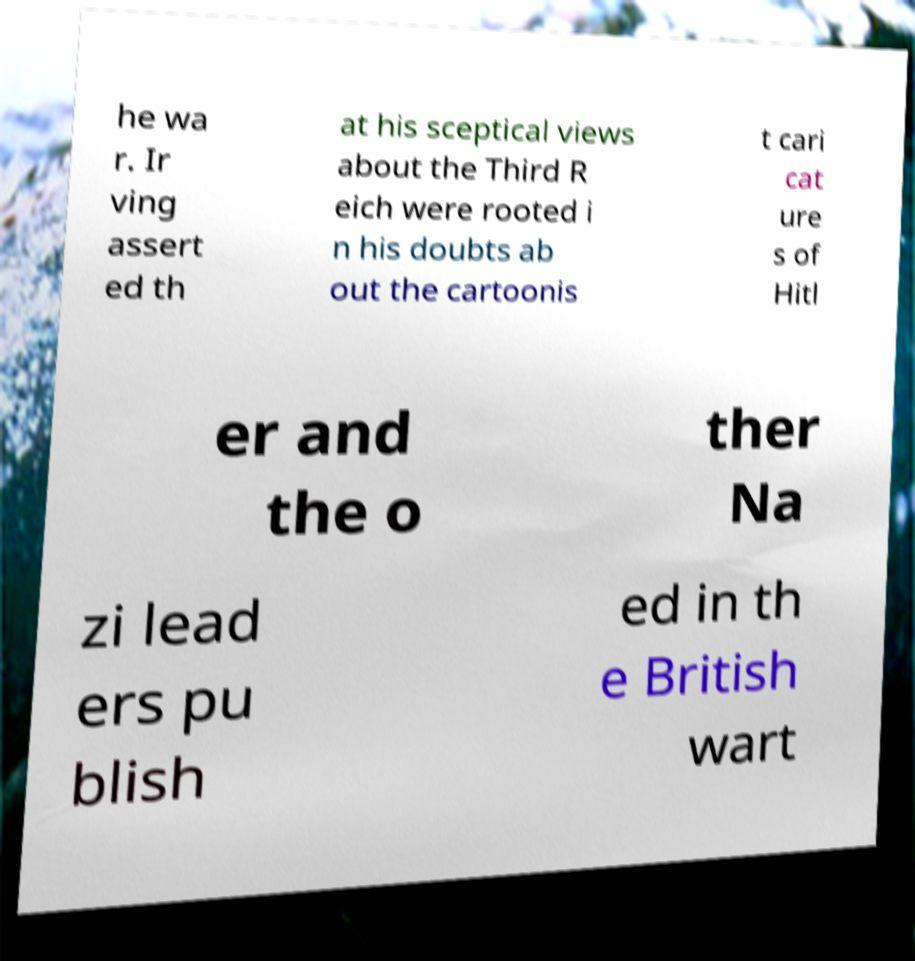Can you accurately transcribe the text from the provided image for me? he wa r. Ir ving assert ed th at his sceptical views about the Third R eich were rooted i n his doubts ab out the cartoonis t cari cat ure s of Hitl er and the o ther Na zi lead ers pu blish ed in th e British wart 